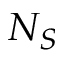Convert formula to latex. <formula><loc_0><loc_0><loc_500><loc_500>N _ { S }</formula> 